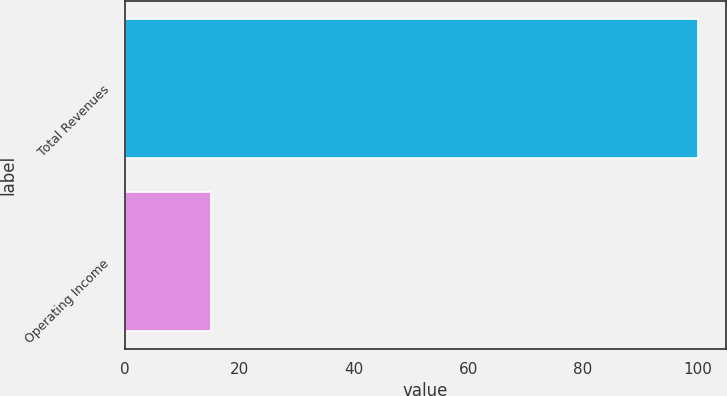Convert chart. <chart><loc_0><loc_0><loc_500><loc_500><bar_chart><fcel>Total Revenues<fcel>Operating Income<nl><fcel>100<fcel>15<nl></chart> 